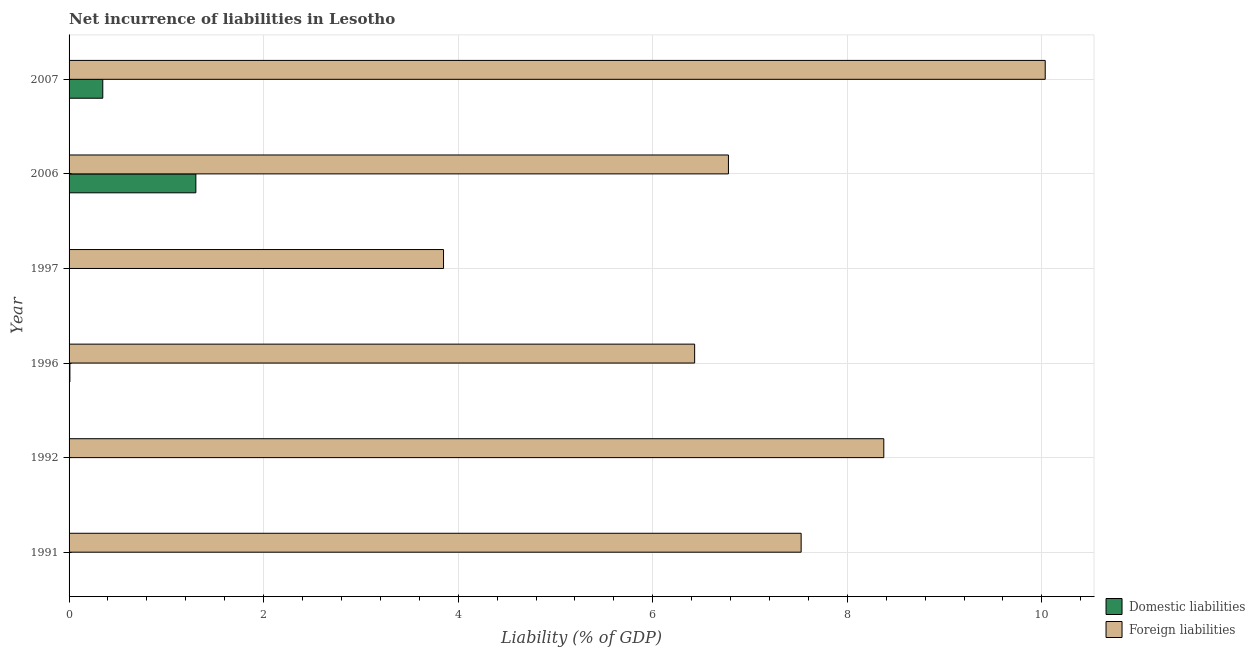How many different coloured bars are there?
Make the answer very short. 2. How many bars are there on the 3rd tick from the top?
Offer a very short reply. 1. In how many cases, is the number of bars for a given year not equal to the number of legend labels?
Offer a terse response. 3. What is the incurrence of domestic liabilities in 1996?
Your answer should be very brief. 0.01. Across all years, what is the maximum incurrence of foreign liabilities?
Ensure brevity in your answer.  10.03. Across all years, what is the minimum incurrence of foreign liabilities?
Make the answer very short. 3.85. What is the total incurrence of foreign liabilities in the graph?
Your response must be concise. 42.99. What is the difference between the incurrence of foreign liabilities in 1991 and that in 2006?
Give a very brief answer. 0.75. What is the difference between the incurrence of domestic liabilities in 1997 and the incurrence of foreign liabilities in 1992?
Give a very brief answer. -8.37. What is the average incurrence of domestic liabilities per year?
Give a very brief answer. 0.28. In the year 2007, what is the difference between the incurrence of domestic liabilities and incurrence of foreign liabilities?
Make the answer very short. -9.69. What is the ratio of the incurrence of foreign liabilities in 1991 to that in 2007?
Offer a terse response. 0.75. What is the difference between the highest and the second highest incurrence of foreign liabilities?
Your response must be concise. 1.66. What is the difference between the highest and the lowest incurrence of foreign liabilities?
Make the answer very short. 6.18. In how many years, is the incurrence of foreign liabilities greater than the average incurrence of foreign liabilities taken over all years?
Provide a short and direct response. 3. Is the sum of the incurrence of foreign liabilities in 1992 and 1996 greater than the maximum incurrence of domestic liabilities across all years?
Give a very brief answer. Yes. How many years are there in the graph?
Make the answer very short. 6. Are the values on the major ticks of X-axis written in scientific E-notation?
Ensure brevity in your answer.  No. Does the graph contain any zero values?
Your answer should be compact. Yes. How many legend labels are there?
Provide a short and direct response. 2. What is the title of the graph?
Make the answer very short. Net incurrence of liabilities in Lesotho. Does "Female population" appear as one of the legend labels in the graph?
Your answer should be very brief. No. What is the label or title of the X-axis?
Provide a short and direct response. Liability (% of GDP). What is the label or title of the Y-axis?
Your answer should be compact. Year. What is the Liability (% of GDP) in Domestic liabilities in 1991?
Offer a very short reply. 0. What is the Liability (% of GDP) of Foreign liabilities in 1991?
Give a very brief answer. 7.53. What is the Liability (% of GDP) in Domestic liabilities in 1992?
Your answer should be compact. 0. What is the Liability (% of GDP) in Foreign liabilities in 1992?
Keep it short and to the point. 8.37. What is the Liability (% of GDP) in Domestic liabilities in 1996?
Your answer should be very brief. 0.01. What is the Liability (% of GDP) of Foreign liabilities in 1996?
Offer a very short reply. 6.43. What is the Liability (% of GDP) in Foreign liabilities in 1997?
Offer a very short reply. 3.85. What is the Liability (% of GDP) of Domestic liabilities in 2006?
Keep it short and to the point. 1.3. What is the Liability (% of GDP) of Foreign liabilities in 2006?
Your answer should be very brief. 6.78. What is the Liability (% of GDP) of Domestic liabilities in 2007?
Make the answer very short. 0.35. What is the Liability (% of GDP) in Foreign liabilities in 2007?
Make the answer very short. 10.03. Across all years, what is the maximum Liability (% of GDP) of Domestic liabilities?
Provide a succinct answer. 1.3. Across all years, what is the maximum Liability (% of GDP) of Foreign liabilities?
Offer a very short reply. 10.03. Across all years, what is the minimum Liability (% of GDP) in Domestic liabilities?
Provide a succinct answer. 0. Across all years, what is the minimum Liability (% of GDP) of Foreign liabilities?
Your answer should be very brief. 3.85. What is the total Liability (% of GDP) in Domestic liabilities in the graph?
Give a very brief answer. 1.66. What is the total Liability (% of GDP) in Foreign liabilities in the graph?
Your answer should be compact. 42.99. What is the difference between the Liability (% of GDP) of Foreign liabilities in 1991 and that in 1992?
Keep it short and to the point. -0.85. What is the difference between the Liability (% of GDP) in Foreign liabilities in 1991 and that in 1996?
Provide a succinct answer. 1.09. What is the difference between the Liability (% of GDP) in Foreign liabilities in 1991 and that in 1997?
Give a very brief answer. 3.68. What is the difference between the Liability (% of GDP) of Foreign liabilities in 1991 and that in 2006?
Your answer should be compact. 0.75. What is the difference between the Liability (% of GDP) in Foreign liabilities in 1991 and that in 2007?
Offer a very short reply. -2.51. What is the difference between the Liability (% of GDP) in Foreign liabilities in 1992 and that in 1996?
Make the answer very short. 1.94. What is the difference between the Liability (% of GDP) of Foreign liabilities in 1992 and that in 1997?
Give a very brief answer. 4.53. What is the difference between the Liability (% of GDP) of Foreign liabilities in 1992 and that in 2006?
Offer a terse response. 1.6. What is the difference between the Liability (% of GDP) of Foreign liabilities in 1992 and that in 2007?
Your answer should be very brief. -1.66. What is the difference between the Liability (% of GDP) in Foreign liabilities in 1996 and that in 1997?
Provide a short and direct response. 2.58. What is the difference between the Liability (% of GDP) in Domestic liabilities in 1996 and that in 2006?
Provide a succinct answer. -1.29. What is the difference between the Liability (% of GDP) of Foreign liabilities in 1996 and that in 2006?
Give a very brief answer. -0.35. What is the difference between the Liability (% of GDP) of Domestic liabilities in 1996 and that in 2007?
Offer a very short reply. -0.34. What is the difference between the Liability (% of GDP) of Foreign liabilities in 1996 and that in 2007?
Your response must be concise. -3.6. What is the difference between the Liability (% of GDP) in Foreign liabilities in 1997 and that in 2006?
Your answer should be compact. -2.93. What is the difference between the Liability (% of GDP) of Foreign liabilities in 1997 and that in 2007?
Provide a short and direct response. -6.18. What is the difference between the Liability (% of GDP) of Domestic liabilities in 2006 and that in 2007?
Your answer should be very brief. 0.96. What is the difference between the Liability (% of GDP) in Foreign liabilities in 2006 and that in 2007?
Provide a short and direct response. -3.26. What is the difference between the Liability (% of GDP) of Domestic liabilities in 1996 and the Liability (% of GDP) of Foreign liabilities in 1997?
Ensure brevity in your answer.  -3.84. What is the difference between the Liability (% of GDP) of Domestic liabilities in 1996 and the Liability (% of GDP) of Foreign liabilities in 2006?
Your answer should be compact. -6.77. What is the difference between the Liability (% of GDP) of Domestic liabilities in 1996 and the Liability (% of GDP) of Foreign liabilities in 2007?
Give a very brief answer. -10.03. What is the difference between the Liability (% of GDP) of Domestic liabilities in 2006 and the Liability (% of GDP) of Foreign liabilities in 2007?
Make the answer very short. -8.73. What is the average Liability (% of GDP) of Domestic liabilities per year?
Provide a succinct answer. 0.28. What is the average Liability (% of GDP) of Foreign liabilities per year?
Your response must be concise. 7.17. In the year 1996, what is the difference between the Liability (% of GDP) of Domestic liabilities and Liability (% of GDP) of Foreign liabilities?
Provide a succinct answer. -6.42. In the year 2006, what is the difference between the Liability (% of GDP) in Domestic liabilities and Liability (% of GDP) in Foreign liabilities?
Keep it short and to the point. -5.47. In the year 2007, what is the difference between the Liability (% of GDP) of Domestic liabilities and Liability (% of GDP) of Foreign liabilities?
Offer a very short reply. -9.69. What is the ratio of the Liability (% of GDP) in Foreign liabilities in 1991 to that in 1992?
Provide a short and direct response. 0.9. What is the ratio of the Liability (% of GDP) in Foreign liabilities in 1991 to that in 1996?
Your response must be concise. 1.17. What is the ratio of the Liability (% of GDP) in Foreign liabilities in 1991 to that in 1997?
Provide a short and direct response. 1.96. What is the ratio of the Liability (% of GDP) in Foreign liabilities in 1991 to that in 2006?
Your answer should be very brief. 1.11. What is the ratio of the Liability (% of GDP) in Foreign liabilities in 1991 to that in 2007?
Provide a short and direct response. 0.75. What is the ratio of the Liability (% of GDP) of Foreign liabilities in 1992 to that in 1996?
Your answer should be compact. 1.3. What is the ratio of the Liability (% of GDP) in Foreign liabilities in 1992 to that in 1997?
Ensure brevity in your answer.  2.18. What is the ratio of the Liability (% of GDP) in Foreign liabilities in 1992 to that in 2006?
Your answer should be compact. 1.24. What is the ratio of the Liability (% of GDP) of Foreign liabilities in 1992 to that in 2007?
Make the answer very short. 0.83. What is the ratio of the Liability (% of GDP) in Foreign liabilities in 1996 to that in 1997?
Your response must be concise. 1.67. What is the ratio of the Liability (% of GDP) in Domestic liabilities in 1996 to that in 2006?
Provide a succinct answer. 0.01. What is the ratio of the Liability (% of GDP) of Foreign liabilities in 1996 to that in 2006?
Offer a terse response. 0.95. What is the ratio of the Liability (% of GDP) in Domestic liabilities in 1996 to that in 2007?
Give a very brief answer. 0.02. What is the ratio of the Liability (% of GDP) in Foreign liabilities in 1996 to that in 2007?
Provide a short and direct response. 0.64. What is the ratio of the Liability (% of GDP) of Foreign liabilities in 1997 to that in 2006?
Provide a succinct answer. 0.57. What is the ratio of the Liability (% of GDP) of Foreign liabilities in 1997 to that in 2007?
Provide a succinct answer. 0.38. What is the ratio of the Liability (% of GDP) of Domestic liabilities in 2006 to that in 2007?
Provide a short and direct response. 3.76. What is the ratio of the Liability (% of GDP) of Foreign liabilities in 2006 to that in 2007?
Provide a short and direct response. 0.68. What is the difference between the highest and the second highest Liability (% of GDP) in Domestic liabilities?
Make the answer very short. 0.96. What is the difference between the highest and the second highest Liability (% of GDP) in Foreign liabilities?
Your answer should be compact. 1.66. What is the difference between the highest and the lowest Liability (% of GDP) in Domestic liabilities?
Your answer should be very brief. 1.3. What is the difference between the highest and the lowest Liability (% of GDP) of Foreign liabilities?
Ensure brevity in your answer.  6.18. 